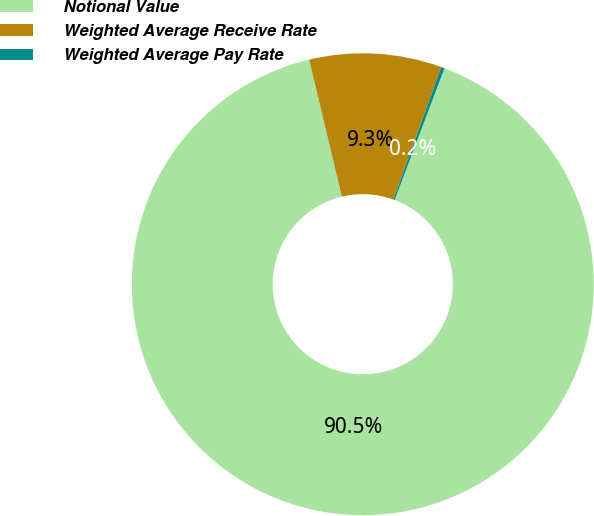<chart> <loc_0><loc_0><loc_500><loc_500><pie_chart><fcel>Notional Value<fcel>Weighted Average Receive Rate<fcel>Weighted Average Pay Rate<nl><fcel>90.52%<fcel>9.26%<fcel>0.23%<nl></chart> 